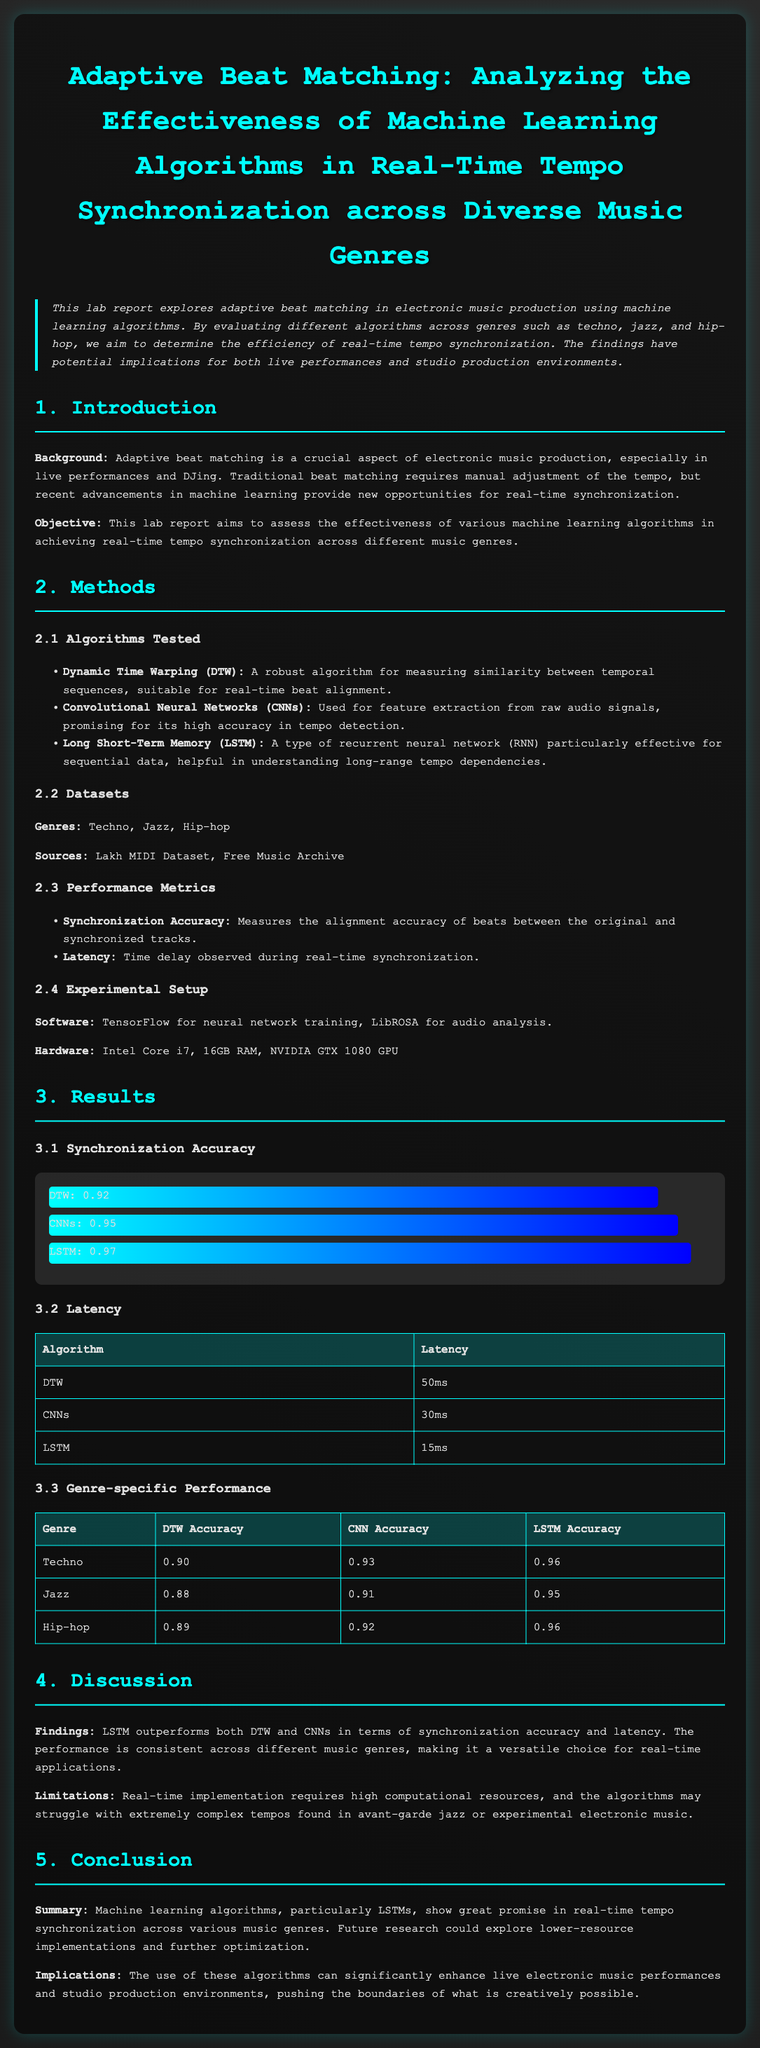What is the main objective of the lab report? The objective is to assess the effectiveness of various machine learning algorithms in achieving real-time tempo synchronization across different music genres.
Answer: effectiveness of various machine learning algorithms Which algorithm had the highest synchronization accuracy? The algorithm with the highest synchronization accuracy, as shown in the results section, is LSTM with an accuracy of 0.97.
Answer: 0.97 What genres were tested in the study? The genres tested were specified in the methods section. They include techno, jazz, and hip-hop.
Answer: Techno, Jazz, Hip-hop What was the latency of the LSTM algorithm? The latency for the LSTM algorithm is stated in the results section and is noted as 15ms.
Answer: 15ms Which performance metric measures the alignment accuracy? The performance metric that measures alignment accuracy is mentioned in the methods section under performance metrics.
Answer: Synchronization Accuracy How do the results of LSTM compare to DTW and CNNs in terms of accuracy? The results show that LSTM outperforms both DTW and CNNs in terms of synchronization accuracy, indicating superior performance in the document.
Answer: LSTM outperforms DTW and CNNs What software was used for neural network training? The software for neural network training is mentioned in the experimental setup section of the document.
Answer: TensorFlow What limitation is noted regarding real-time implementation? A limitation highlighted in the discussion section relates to high computational resources required for real-time implementation.
Answer: high computational resources 